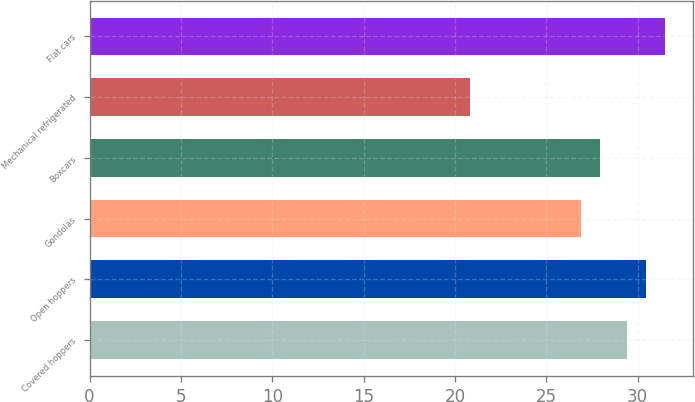Convert chart. <chart><loc_0><loc_0><loc_500><loc_500><bar_chart><fcel>Covered hoppers<fcel>Open hoppers<fcel>Gondolas<fcel>Boxcars<fcel>Mechanical refrigerated<fcel>Flat cars<nl><fcel>29.4<fcel>30.44<fcel>26.9<fcel>27.94<fcel>20.8<fcel>31.48<nl></chart> 